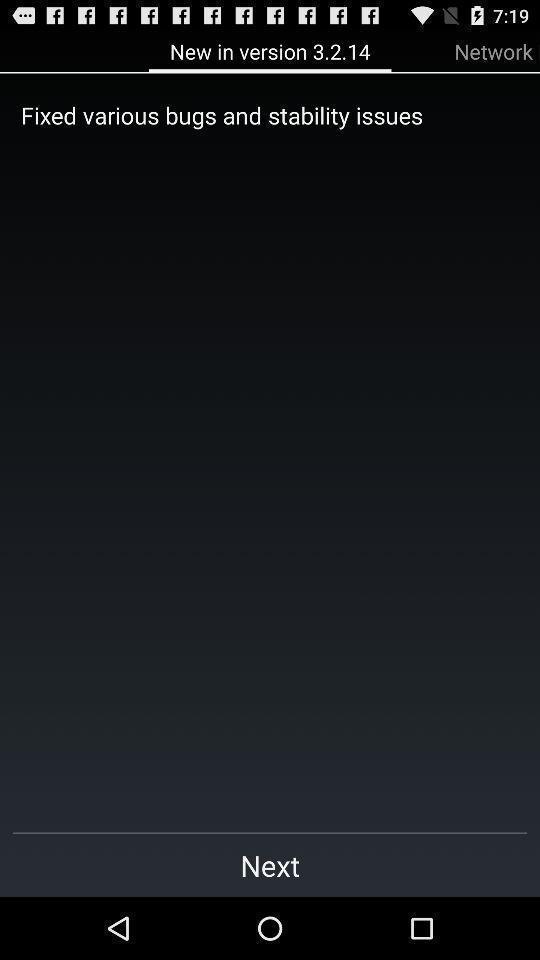Provide a description of this screenshot. Screen displaying the new version. 